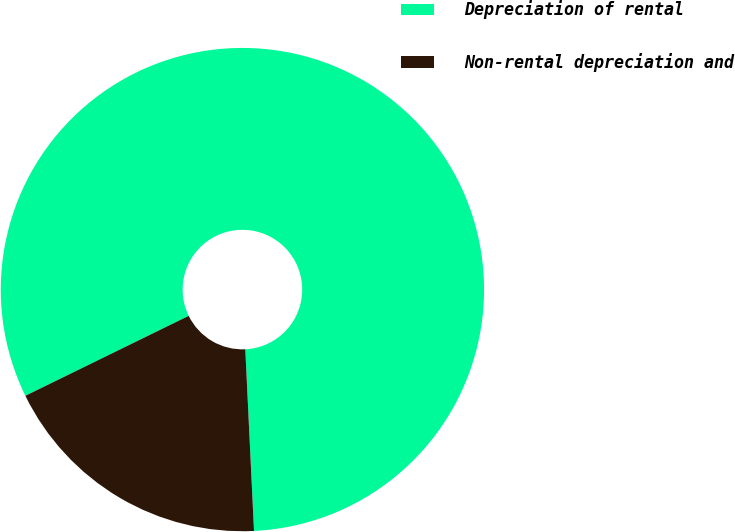Convert chart to OTSL. <chart><loc_0><loc_0><loc_500><loc_500><pie_chart><fcel>Depreciation of rental<fcel>Non-rental depreciation and<nl><fcel>81.48%<fcel>18.52%<nl></chart> 